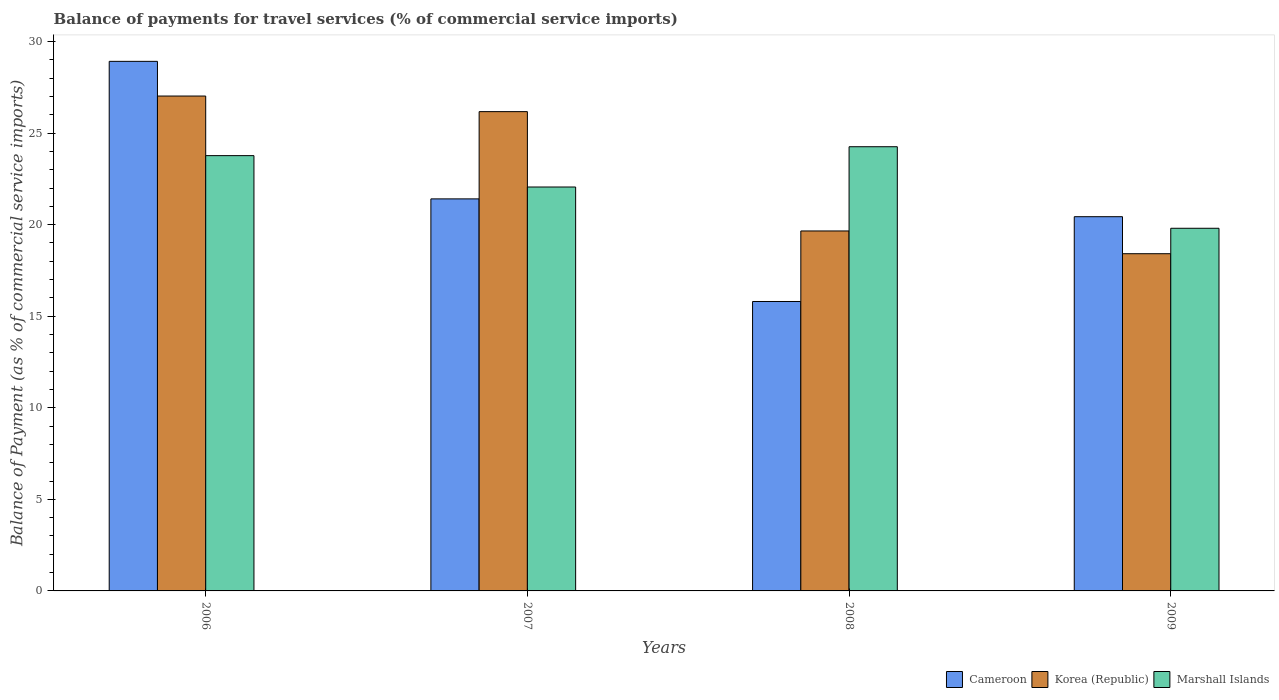Are the number of bars per tick equal to the number of legend labels?
Your answer should be very brief. Yes. Are the number of bars on each tick of the X-axis equal?
Offer a terse response. Yes. How many bars are there on the 4th tick from the right?
Make the answer very short. 3. What is the balance of payments for travel services in Korea (Republic) in 2007?
Keep it short and to the point. 26.17. Across all years, what is the maximum balance of payments for travel services in Marshall Islands?
Provide a succinct answer. 24.26. Across all years, what is the minimum balance of payments for travel services in Cameroon?
Your answer should be very brief. 15.81. What is the total balance of payments for travel services in Korea (Republic) in the graph?
Give a very brief answer. 91.27. What is the difference between the balance of payments for travel services in Korea (Republic) in 2006 and that in 2008?
Your answer should be compact. 7.37. What is the difference between the balance of payments for travel services in Korea (Republic) in 2008 and the balance of payments for travel services in Marshall Islands in 2006?
Offer a very short reply. -4.11. What is the average balance of payments for travel services in Marshall Islands per year?
Provide a short and direct response. 22.47. In the year 2008, what is the difference between the balance of payments for travel services in Cameroon and balance of payments for travel services in Korea (Republic)?
Your answer should be compact. -3.85. What is the ratio of the balance of payments for travel services in Marshall Islands in 2006 to that in 2007?
Give a very brief answer. 1.08. Is the balance of payments for travel services in Cameroon in 2008 less than that in 2009?
Offer a terse response. Yes. What is the difference between the highest and the second highest balance of payments for travel services in Cameroon?
Keep it short and to the point. 7.51. What is the difference between the highest and the lowest balance of payments for travel services in Korea (Republic)?
Give a very brief answer. 8.61. Is the sum of the balance of payments for travel services in Marshall Islands in 2006 and 2009 greater than the maximum balance of payments for travel services in Cameroon across all years?
Your response must be concise. Yes. What does the 1st bar from the left in 2006 represents?
Offer a terse response. Cameroon. What does the 2nd bar from the right in 2008 represents?
Your answer should be very brief. Korea (Republic). Is it the case that in every year, the sum of the balance of payments for travel services in Korea (Republic) and balance of payments for travel services in Marshall Islands is greater than the balance of payments for travel services in Cameroon?
Your answer should be very brief. Yes. How many years are there in the graph?
Ensure brevity in your answer.  4. Does the graph contain any zero values?
Offer a very short reply. No. Where does the legend appear in the graph?
Provide a short and direct response. Bottom right. How are the legend labels stacked?
Ensure brevity in your answer.  Horizontal. What is the title of the graph?
Your answer should be compact. Balance of payments for travel services (% of commercial service imports). Does "Costa Rica" appear as one of the legend labels in the graph?
Give a very brief answer. No. What is the label or title of the Y-axis?
Your response must be concise. Balance of Payment (as % of commercial service imports). What is the Balance of Payment (as % of commercial service imports) of Cameroon in 2006?
Provide a short and direct response. 28.92. What is the Balance of Payment (as % of commercial service imports) in Korea (Republic) in 2006?
Provide a succinct answer. 27.03. What is the Balance of Payment (as % of commercial service imports) of Marshall Islands in 2006?
Offer a terse response. 23.77. What is the Balance of Payment (as % of commercial service imports) in Cameroon in 2007?
Offer a very short reply. 21.41. What is the Balance of Payment (as % of commercial service imports) in Korea (Republic) in 2007?
Your answer should be very brief. 26.17. What is the Balance of Payment (as % of commercial service imports) in Marshall Islands in 2007?
Ensure brevity in your answer.  22.06. What is the Balance of Payment (as % of commercial service imports) in Cameroon in 2008?
Ensure brevity in your answer.  15.81. What is the Balance of Payment (as % of commercial service imports) of Korea (Republic) in 2008?
Offer a terse response. 19.66. What is the Balance of Payment (as % of commercial service imports) of Marshall Islands in 2008?
Give a very brief answer. 24.26. What is the Balance of Payment (as % of commercial service imports) in Cameroon in 2009?
Provide a short and direct response. 20.44. What is the Balance of Payment (as % of commercial service imports) of Korea (Republic) in 2009?
Make the answer very short. 18.41. What is the Balance of Payment (as % of commercial service imports) in Marshall Islands in 2009?
Offer a very short reply. 19.8. Across all years, what is the maximum Balance of Payment (as % of commercial service imports) of Cameroon?
Give a very brief answer. 28.92. Across all years, what is the maximum Balance of Payment (as % of commercial service imports) of Korea (Republic)?
Provide a succinct answer. 27.03. Across all years, what is the maximum Balance of Payment (as % of commercial service imports) in Marshall Islands?
Your answer should be compact. 24.26. Across all years, what is the minimum Balance of Payment (as % of commercial service imports) in Cameroon?
Provide a succinct answer. 15.81. Across all years, what is the minimum Balance of Payment (as % of commercial service imports) in Korea (Republic)?
Your answer should be compact. 18.41. Across all years, what is the minimum Balance of Payment (as % of commercial service imports) of Marshall Islands?
Your response must be concise. 19.8. What is the total Balance of Payment (as % of commercial service imports) of Cameroon in the graph?
Give a very brief answer. 86.57. What is the total Balance of Payment (as % of commercial service imports) of Korea (Republic) in the graph?
Your answer should be very brief. 91.27. What is the total Balance of Payment (as % of commercial service imports) of Marshall Islands in the graph?
Provide a short and direct response. 89.89. What is the difference between the Balance of Payment (as % of commercial service imports) of Cameroon in 2006 and that in 2007?
Provide a succinct answer. 7.51. What is the difference between the Balance of Payment (as % of commercial service imports) of Korea (Republic) in 2006 and that in 2007?
Keep it short and to the point. 0.85. What is the difference between the Balance of Payment (as % of commercial service imports) of Marshall Islands in 2006 and that in 2007?
Provide a short and direct response. 1.71. What is the difference between the Balance of Payment (as % of commercial service imports) in Cameroon in 2006 and that in 2008?
Offer a terse response. 13.11. What is the difference between the Balance of Payment (as % of commercial service imports) in Korea (Republic) in 2006 and that in 2008?
Your response must be concise. 7.37. What is the difference between the Balance of Payment (as % of commercial service imports) of Marshall Islands in 2006 and that in 2008?
Give a very brief answer. -0.49. What is the difference between the Balance of Payment (as % of commercial service imports) of Cameroon in 2006 and that in 2009?
Provide a succinct answer. 8.48. What is the difference between the Balance of Payment (as % of commercial service imports) of Korea (Republic) in 2006 and that in 2009?
Make the answer very short. 8.61. What is the difference between the Balance of Payment (as % of commercial service imports) of Marshall Islands in 2006 and that in 2009?
Your response must be concise. 3.97. What is the difference between the Balance of Payment (as % of commercial service imports) in Cameroon in 2007 and that in 2008?
Your answer should be very brief. 5.6. What is the difference between the Balance of Payment (as % of commercial service imports) of Korea (Republic) in 2007 and that in 2008?
Provide a short and direct response. 6.52. What is the difference between the Balance of Payment (as % of commercial service imports) in Marshall Islands in 2007 and that in 2008?
Make the answer very short. -2.2. What is the difference between the Balance of Payment (as % of commercial service imports) of Cameroon in 2007 and that in 2009?
Make the answer very short. 0.97. What is the difference between the Balance of Payment (as % of commercial service imports) of Korea (Republic) in 2007 and that in 2009?
Make the answer very short. 7.76. What is the difference between the Balance of Payment (as % of commercial service imports) in Marshall Islands in 2007 and that in 2009?
Keep it short and to the point. 2.25. What is the difference between the Balance of Payment (as % of commercial service imports) in Cameroon in 2008 and that in 2009?
Your answer should be compact. -4.63. What is the difference between the Balance of Payment (as % of commercial service imports) in Korea (Republic) in 2008 and that in 2009?
Offer a terse response. 1.24. What is the difference between the Balance of Payment (as % of commercial service imports) of Marshall Islands in 2008 and that in 2009?
Offer a terse response. 4.45. What is the difference between the Balance of Payment (as % of commercial service imports) in Cameroon in 2006 and the Balance of Payment (as % of commercial service imports) in Korea (Republic) in 2007?
Give a very brief answer. 2.75. What is the difference between the Balance of Payment (as % of commercial service imports) of Cameroon in 2006 and the Balance of Payment (as % of commercial service imports) of Marshall Islands in 2007?
Provide a succinct answer. 6.86. What is the difference between the Balance of Payment (as % of commercial service imports) in Korea (Republic) in 2006 and the Balance of Payment (as % of commercial service imports) in Marshall Islands in 2007?
Offer a terse response. 4.97. What is the difference between the Balance of Payment (as % of commercial service imports) of Cameroon in 2006 and the Balance of Payment (as % of commercial service imports) of Korea (Republic) in 2008?
Offer a terse response. 9.26. What is the difference between the Balance of Payment (as % of commercial service imports) in Cameroon in 2006 and the Balance of Payment (as % of commercial service imports) in Marshall Islands in 2008?
Provide a short and direct response. 4.66. What is the difference between the Balance of Payment (as % of commercial service imports) of Korea (Republic) in 2006 and the Balance of Payment (as % of commercial service imports) of Marshall Islands in 2008?
Make the answer very short. 2.77. What is the difference between the Balance of Payment (as % of commercial service imports) in Cameroon in 2006 and the Balance of Payment (as % of commercial service imports) in Korea (Republic) in 2009?
Give a very brief answer. 10.5. What is the difference between the Balance of Payment (as % of commercial service imports) in Cameroon in 2006 and the Balance of Payment (as % of commercial service imports) in Marshall Islands in 2009?
Offer a very short reply. 9.12. What is the difference between the Balance of Payment (as % of commercial service imports) of Korea (Republic) in 2006 and the Balance of Payment (as % of commercial service imports) of Marshall Islands in 2009?
Offer a terse response. 7.22. What is the difference between the Balance of Payment (as % of commercial service imports) of Cameroon in 2007 and the Balance of Payment (as % of commercial service imports) of Korea (Republic) in 2008?
Your answer should be very brief. 1.75. What is the difference between the Balance of Payment (as % of commercial service imports) in Cameroon in 2007 and the Balance of Payment (as % of commercial service imports) in Marshall Islands in 2008?
Offer a terse response. -2.85. What is the difference between the Balance of Payment (as % of commercial service imports) in Korea (Republic) in 2007 and the Balance of Payment (as % of commercial service imports) in Marshall Islands in 2008?
Offer a terse response. 1.92. What is the difference between the Balance of Payment (as % of commercial service imports) in Cameroon in 2007 and the Balance of Payment (as % of commercial service imports) in Korea (Republic) in 2009?
Provide a short and direct response. 2.99. What is the difference between the Balance of Payment (as % of commercial service imports) of Cameroon in 2007 and the Balance of Payment (as % of commercial service imports) of Marshall Islands in 2009?
Give a very brief answer. 1.6. What is the difference between the Balance of Payment (as % of commercial service imports) of Korea (Republic) in 2007 and the Balance of Payment (as % of commercial service imports) of Marshall Islands in 2009?
Make the answer very short. 6.37. What is the difference between the Balance of Payment (as % of commercial service imports) of Cameroon in 2008 and the Balance of Payment (as % of commercial service imports) of Korea (Republic) in 2009?
Offer a terse response. -2.61. What is the difference between the Balance of Payment (as % of commercial service imports) in Cameroon in 2008 and the Balance of Payment (as % of commercial service imports) in Marshall Islands in 2009?
Offer a very short reply. -4. What is the difference between the Balance of Payment (as % of commercial service imports) of Korea (Republic) in 2008 and the Balance of Payment (as % of commercial service imports) of Marshall Islands in 2009?
Your response must be concise. -0.15. What is the average Balance of Payment (as % of commercial service imports) of Cameroon per year?
Keep it short and to the point. 21.64. What is the average Balance of Payment (as % of commercial service imports) in Korea (Republic) per year?
Make the answer very short. 22.82. What is the average Balance of Payment (as % of commercial service imports) of Marshall Islands per year?
Offer a very short reply. 22.47. In the year 2006, what is the difference between the Balance of Payment (as % of commercial service imports) in Cameroon and Balance of Payment (as % of commercial service imports) in Korea (Republic)?
Provide a succinct answer. 1.89. In the year 2006, what is the difference between the Balance of Payment (as % of commercial service imports) in Cameroon and Balance of Payment (as % of commercial service imports) in Marshall Islands?
Keep it short and to the point. 5.15. In the year 2006, what is the difference between the Balance of Payment (as % of commercial service imports) in Korea (Republic) and Balance of Payment (as % of commercial service imports) in Marshall Islands?
Provide a succinct answer. 3.25. In the year 2007, what is the difference between the Balance of Payment (as % of commercial service imports) in Cameroon and Balance of Payment (as % of commercial service imports) in Korea (Republic)?
Make the answer very short. -4.76. In the year 2007, what is the difference between the Balance of Payment (as % of commercial service imports) in Cameroon and Balance of Payment (as % of commercial service imports) in Marshall Islands?
Your answer should be very brief. -0.65. In the year 2007, what is the difference between the Balance of Payment (as % of commercial service imports) of Korea (Republic) and Balance of Payment (as % of commercial service imports) of Marshall Islands?
Your answer should be very brief. 4.12. In the year 2008, what is the difference between the Balance of Payment (as % of commercial service imports) in Cameroon and Balance of Payment (as % of commercial service imports) in Korea (Republic)?
Your response must be concise. -3.85. In the year 2008, what is the difference between the Balance of Payment (as % of commercial service imports) of Cameroon and Balance of Payment (as % of commercial service imports) of Marshall Islands?
Provide a short and direct response. -8.45. In the year 2008, what is the difference between the Balance of Payment (as % of commercial service imports) of Korea (Republic) and Balance of Payment (as % of commercial service imports) of Marshall Islands?
Your response must be concise. -4.6. In the year 2009, what is the difference between the Balance of Payment (as % of commercial service imports) in Cameroon and Balance of Payment (as % of commercial service imports) in Korea (Republic)?
Offer a very short reply. 2.02. In the year 2009, what is the difference between the Balance of Payment (as % of commercial service imports) of Cameroon and Balance of Payment (as % of commercial service imports) of Marshall Islands?
Ensure brevity in your answer.  0.63. In the year 2009, what is the difference between the Balance of Payment (as % of commercial service imports) of Korea (Republic) and Balance of Payment (as % of commercial service imports) of Marshall Islands?
Offer a terse response. -1.39. What is the ratio of the Balance of Payment (as % of commercial service imports) in Cameroon in 2006 to that in 2007?
Your answer should be very brief. 1.35. What is the ratio of the Balance of Payment (as % of commercial service imports) of Korea (Republic) in 2006 to that in 2007?
Make the answer very short. 1.03. What is the ratio of the Balance of Payment (as % of commercial service imports) of Marshall Islands in 2006 to that in 2007?
Keep it short and to the point. 1.08. What is the ratio of the Balance of Payment (as % of commercial service imports) of Cameroon in 2006 to that in 2008?
Ensure brevity in your answer.  1.83. What is the ratio of the Balance of Payment (as % of commercial service imports) of Korea (Republic) in 2006 to that in 2008?
Give a very brief answer. 1.37. What is the ratio of the Balance of Payment (as % of commercial service imports) in Marshall Islands in 2006 to that in 2008?
Your answer should be compact. 0.98. What is the ratio of the Balance of Payment (as % of commercial service imports) of Cameroon in 2006 to that in 2009?
Make the answer very short. 1.42. What is the ratio of the Balance of Payment (as % of commercial service imports) of Korea (Republic) in 2006 to that in 2009?
Give a very brief answer. 1.47. What is the ratio of the Balance of Payment (as % of commercial service imports) of Marshall Islands in 2006 to that in 2009?
Offer a very short reply. 1.2. What is the ratio of the Balance of Payment (as % of commercial service imports) in Cameroon in 2007 to that in 2008?
Your answer should be compact. 1.35. What is the ratio of the Balance of Payment (as % of commercial service imports) in Korea (Republic) in 2007 to that in 2008?
Ensure brevity in your answer.  1.33. What is the ratio of the Balance of Payment (as % of commercial service imports) in Marshall Islands in 2007 to that in 2008?
Your response must be concise. 0.91. What is the ratio of the Balance of Payment (as % of commercial service imports) of Cameroon in 2007 to that in 2009?
Keep it short and to the point. 1.05. What is the ratio of the Balance of Payment (as % of commercial service imports) of Korea (Republic) in 2007 to that in 2009?
Provide a succinct answer. 1.42. What is the ratio of the Balance of Payment (as % of commercial service imports) of Marshall Islands in 2007 to that in 2009?
Offer a very short reply. 1.11. What is the ratio of the Balance of Payment (as % of commercial service imports) in Cameroon in 2008 to that in 2009?
Provide a short and direct response. 0.77. What is the ratio of the Balance of Payment (as % of commercial service imports) of Korea (Republic) in 2008 to that in 2009?
Your response must be concise. 1.07. What is the ratio of the Balance of Payment (as % of commercial service imports) in Marshall Islands in 2008 to that in 2009?
Keep it short and to the point. 1.22. What is the difference between the highest and the second highest Balance of Payment (as % of commercial service imports) in Cameroon?
Offer a very short reply. 7.51. What is the difference between the highest and the second highest Balance of Payment (as % of commercial service imports) in Korea (Republic)?
Provide a succinct answer. 0.85. What is the difference between the highest and the second highest Balance of Payment (as % of commercial service imports) in Marshall Islands?
Offer a terse response. 0.49. What is the difference between the highest and the lowest Balance of Payment (as % of commercial service imports) in Cameroon?
Keep it short and to the point. 13.11. What is the difference between the highest and the lowest Balance of Payment (as % of commercial service imports) of Korea (Republic)?
Offer a very short reply. 8.61. What is the difference between the highest and the lowest Balance of Payment (as % of commercial service imports) of Marshall Islands?
Provide a short and direct response. 4.45. 